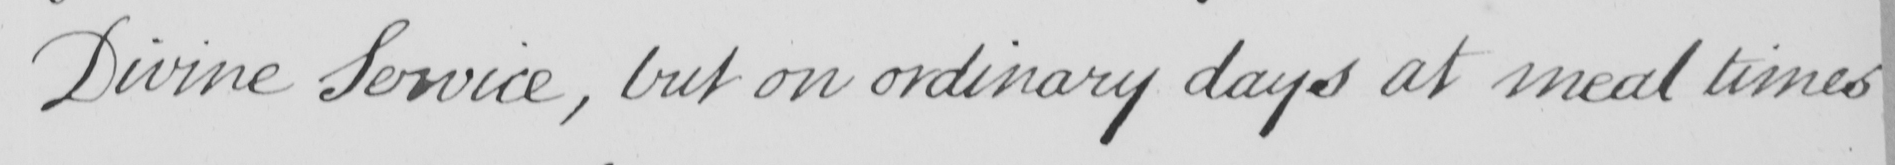Please provide the text content of this handwritten line. Divine Service , but on ordinary days at meal times 